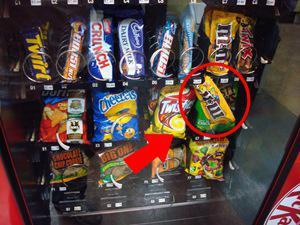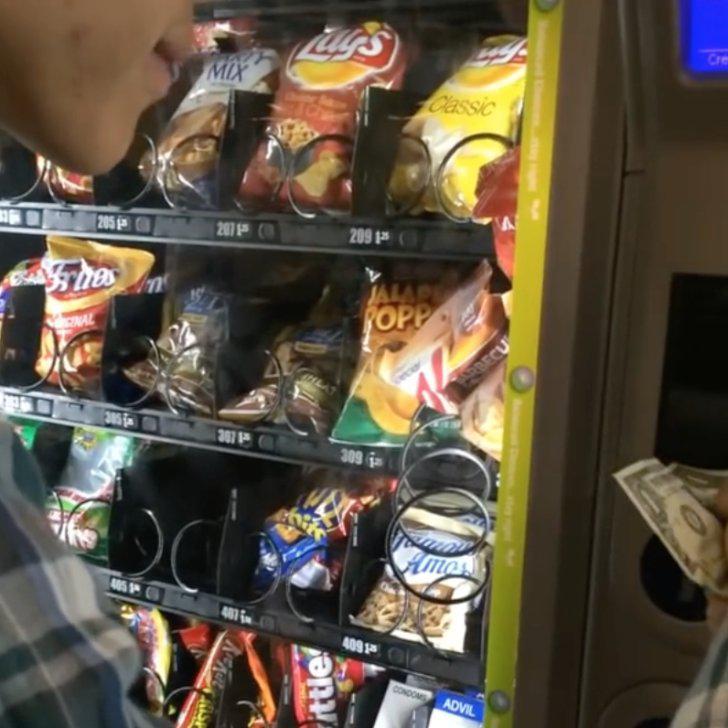The first image is the image on the left, the second image is the image on the right. Examine the images to the left and right. Is the description "One image shows a vending machine front with one bottle at a diagonal, as if falling." accurate? Answer yes or no. No. The first image is the image on the left, the second image is the image on the right. Analyze the images presented: Is the assertion "At least one pack of peanut m&m's is in a vending machine in one of the images." valid? Answer yes or no. Yes. 